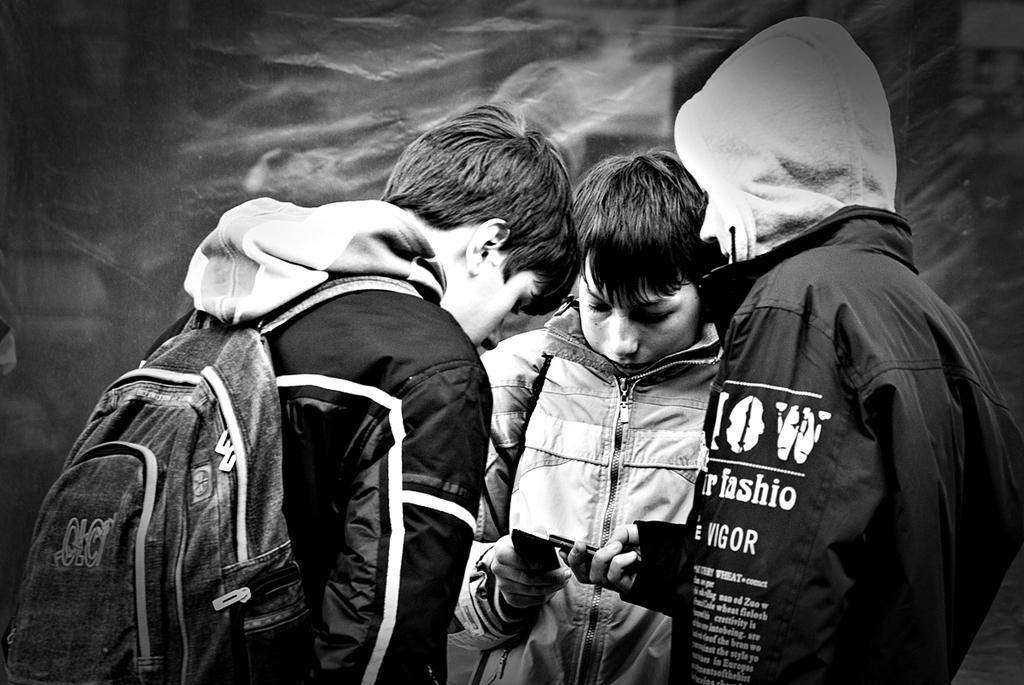What is the person on the right side of the image holding? The person on the right side of the image is holding a mobile phone. What is the person on the left side of the image wearing? The person on the left side of the image is wearing a bag. What type of poison is the person on the left side of the image using? There is no poison present in the image; the person on the left side of the image is wearing a bag. 